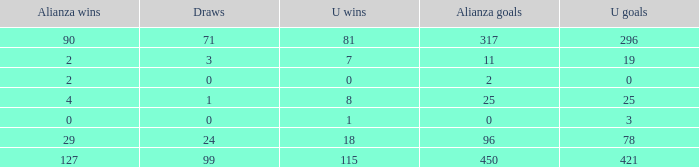What is the lowest U Wins, when Alianza Wins is greater than 0, when Alianza Goals is greater than 25, and when Draws is "99"? 115.0. 